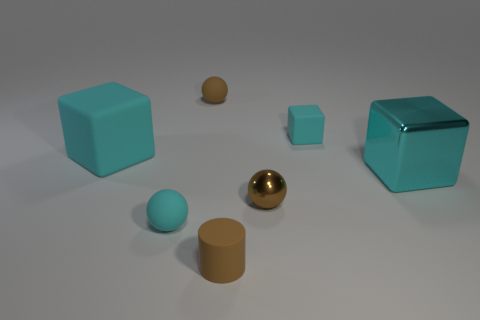How many cyan cubes must be subtracted to get 1 cyan cubes? 2 Add 1 small blue things. How many objects exist? 8 Subtract all cubes. How many objects are left? 4 Add 3 brown metallic things. How many brown metallic things exist? 4 Subtract 0 red cylinders. How many objects are left? 7 Subtract all tiny blue rubber cylinders. Subtract all small brown shiny spheres. How many objects are left? 6 Add 6 cyan objects. How many cyan objects are left? 10 